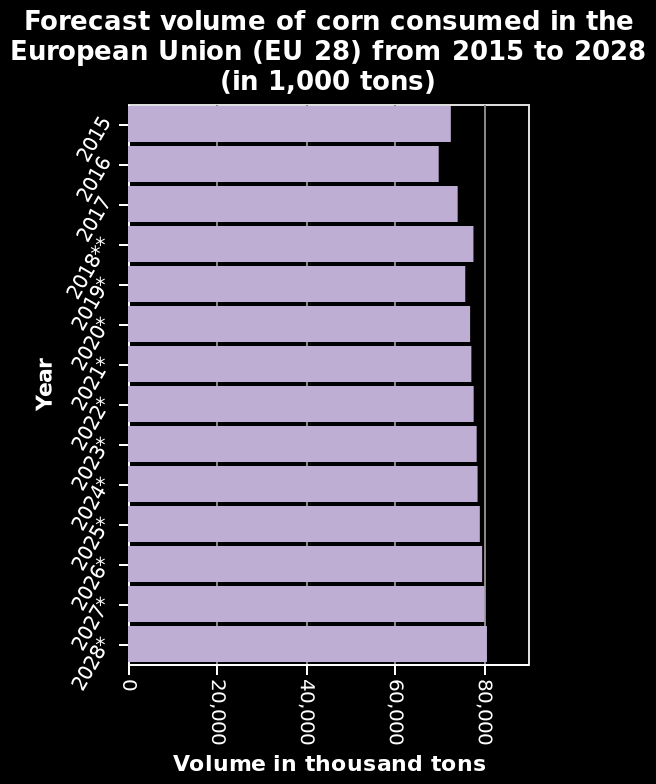<image>
Are there any exceptions in the growth predictions? Yes, there are one or two exceptions in the growth predictions. What does the chart predict about the growth of consumption?  The chart predicts a steady growth in consumption year on year. 